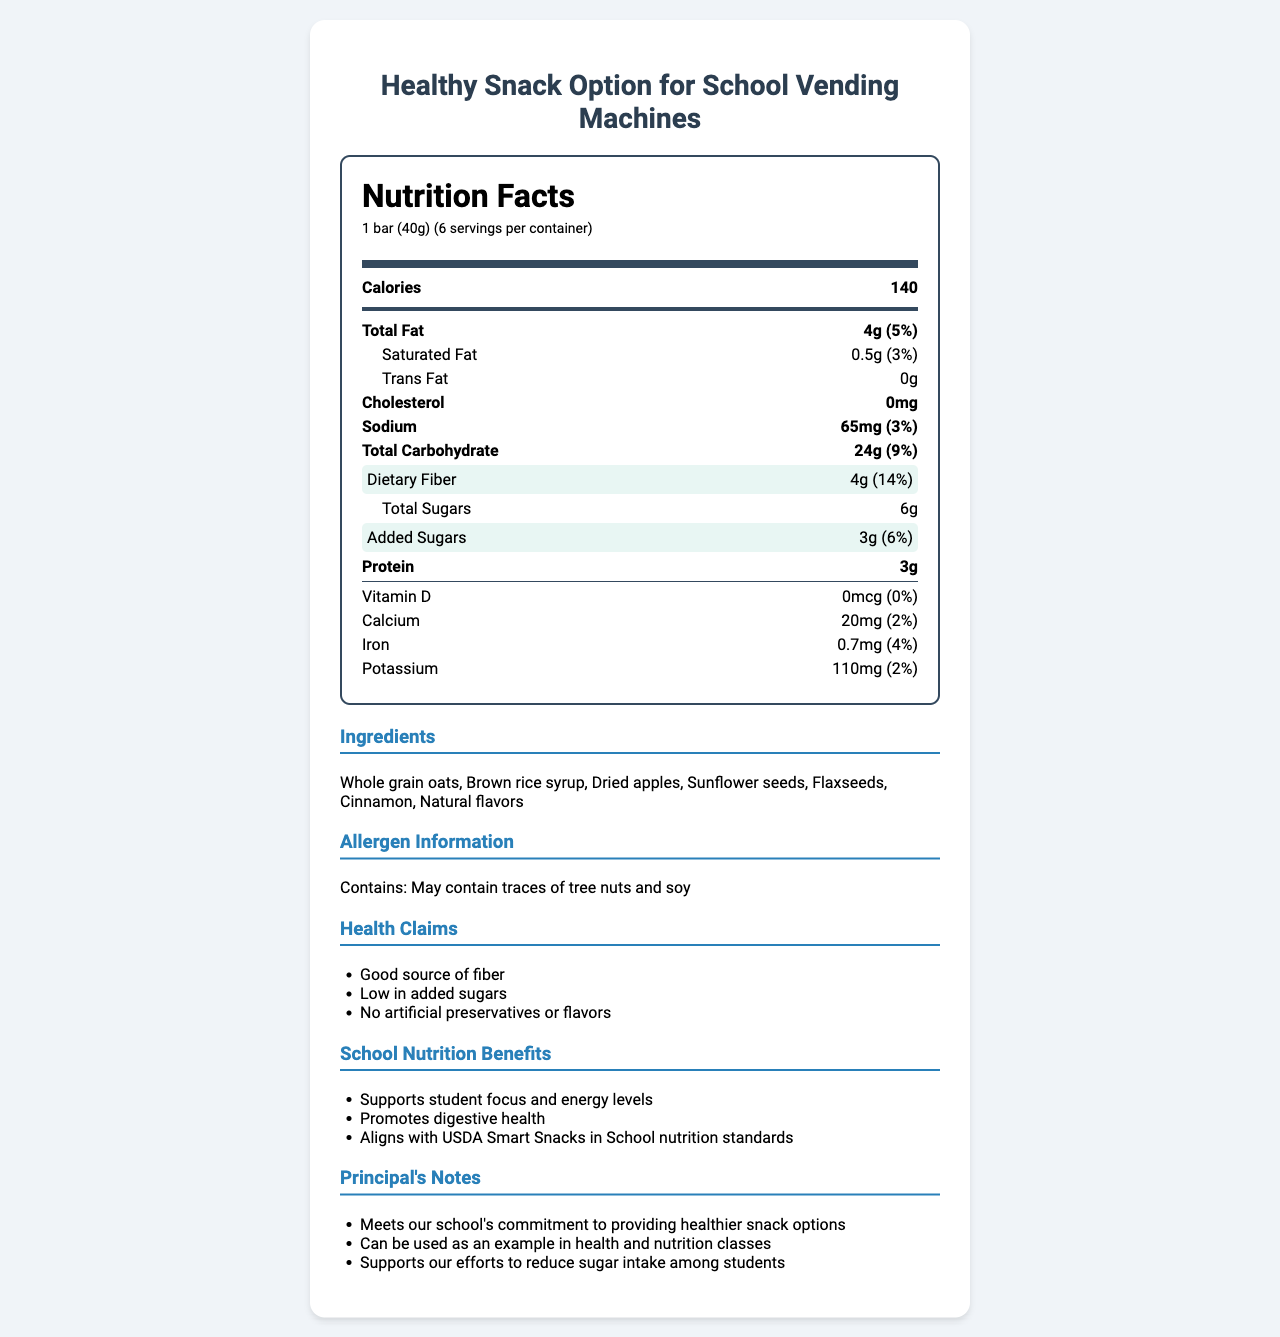what is the serving size of the "Whole Grain Apple Cinnamon Granola Bar"? The document states that the serving size is "1 bar (40g)" under the Nutrition Facts section.
Answer: 1 bar (40g) how many servings are there per container? The document specifies "6 servings per container" right below the serving size information.
Answer: 6 how many grams of dietary fiber does one serving contain? The Dietary Fiber content is highlighted in the "Nutrition Facts" section, showing 4g per serving.
Answer: 4g what percentage of the daily value does the dietary fiber represent? This information can be found in the highlighted section under "Dietary Fiber," showing it is 14% of the daily value.
Answer: 14% what are the ingredients of the granola bar? The document lists the ingredients under the "Ingredients" section.
Answer: Whole grain oats, Brown rice syrup, Dried apples, Sunflower seeds, Flaxseeds, Cinnamon, Natural flavors how much protein is in one serving? The amount of protein per serving is clearly listed as 3g in the "Nutrition Facts" section.
Answer: 3g how much added sugar is in one serving? The document specifies that each serving contains 3g of added sugars in the highlighted section of the "Nutrition Facts."
Answer: 3g which vitamin is present in this granola bar? The document lists Vitamin D as one of the vitamins present, although it mentions it has 0mcg and 0% of the daily value.
Answer: Vitamin D how much sodium is in one serving? A. 50mg B. 65mg C. 70mg D. 40mg In the "Nutrition Facts" section, the sodium amount per serving is specified as 65mg.
Answer: B. 65mg which health claim is NOT made about the granola bar? i. Good source of fiber ii. Low in added sugars iii. Rich in protein iv. No artificial preservatives or flavors The health claims section does not mention "Rich in protein"; it only mentions "Good source of fiber," "Low in added sugars," and "No artificial preservatives or flavors."
Answer: iii. Rich in protein is this product compliant with USDA Smart Snacks in School nutrition standards? The document lists this under the "School Nutrition Benefits" section, stating it "Aligns with USDA Smart Snacks in School nutrition standards."
Answer: Yes summarize the main idea of the document. The document covers the nutritional content, ingredients, health claims, school nutrition benefits, and the principal's notes on the product's contribution to a healthier snack option for students.
Answer: The document provides nutritional information about the "Whole Grain Apple Cinnamon Granola Bar," highlighting its benefits such as being a good source of fiber, low in added sugars, and containing no artificial preservatives or flavors. It also emphasizes its alignment with school nutrition standards and its suitability for promoting student health. what is the brand of the granola bar? The document does not provide the brand name of the "Whole Grain Apple Cinnamon Granola Bar," making it impossible to determine the brand based solely on the given information.
Answer: Not enough information 